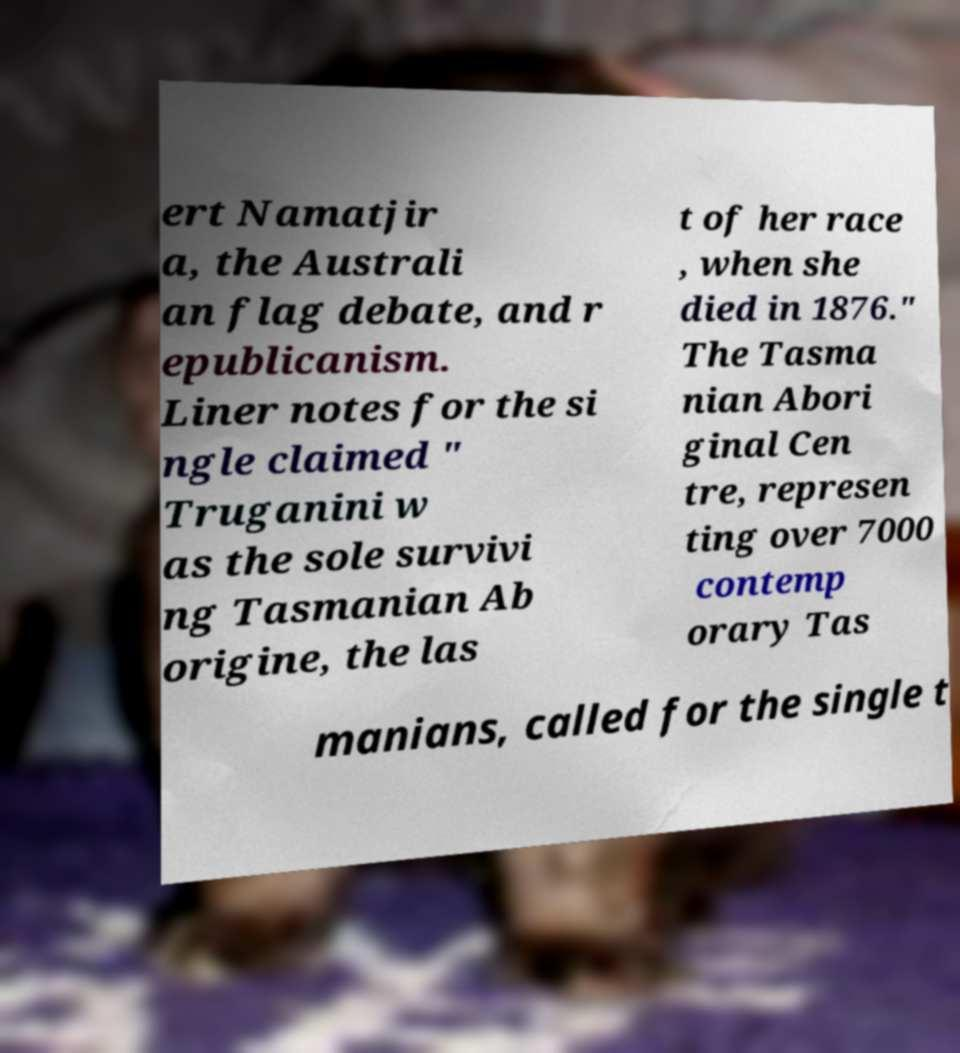What messages or text are displayed in this image? I need them in a readable, typed format. ert Namatjir a, the Australi an flag debate, and r epublicanism. Liner notes for the si ngle claimed " Truganini w as the sole survivi ng Tasmanian Ab origine, the las t of her race , when she died in 1876." The Tasma nian Abori ginal Cen tre, represen ting over 7000 contemp orary Tas manians, called for the single t 